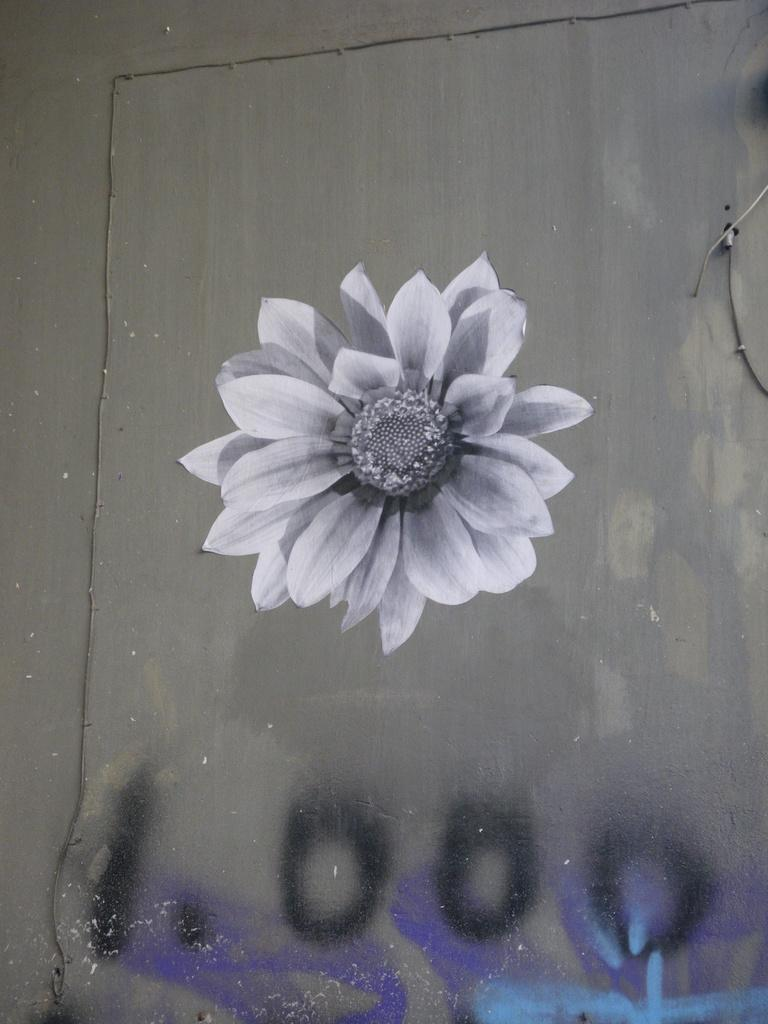What is depicted on the painting that is on the wall in the image? There is a painting of a flower on the wall in the image. What other object can be seen in the image besides the painting? There is a wire in the image. Is there any text or writing present in the image? Yes, there is writing on the wire or a related object in the image. How does the hair on the flower in the painting look like? There is no hair present on the flower in the painting, as flowers do not have hair. 